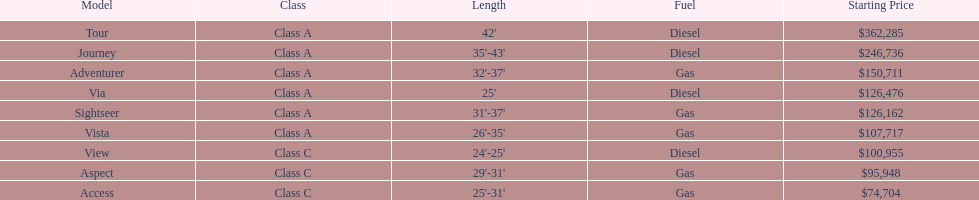Does the vista hold greater significance than the aspect? Yes. 